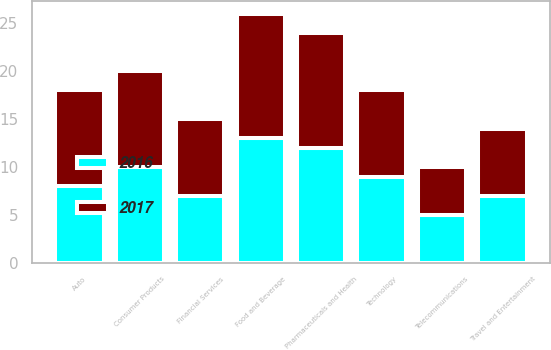Convert chart to OTSL. <chart><loc_0><loc_0><loc_500><loc_500><stacked_bar_chart><ecel><fcel>Food and Beverage<fcel>Consumer Products<fcel>Pharmaceuticals and Health<fcel>Financial Services<fcel>Technology<fcel>Auto<fcel>Travel and Entertainment<fcel>Telecommunications<nl><fcel>2017<fcel>13<fcel>10<fcel>12<fcel>8<fcel>9<fcel>10<fcel>7<fcel>5<nl><fcel>2016<fcel>13<fcel>10<fcel>12<fcel>7<fcel>9<fcel>8<fcel>7<fcel>5<nl></chart> 